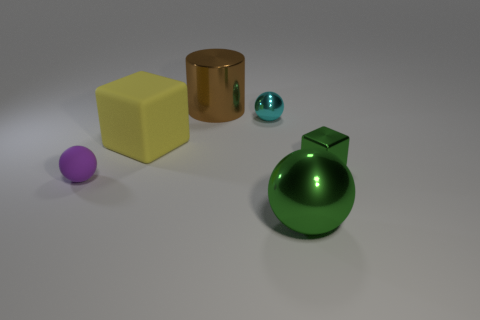What could be the material composition of each object based on their appearance? The big green sphere and the small blue sphere appear to have a reflective surface, suggesting they could be made of polished metal or glass. The yellow cube looks like it could be made of a matte plastic or rubber, whereas the cylinder has a reflective gold-like surface that indicates it could be a polished metal. How does the texture contribute to the perceived material of the objects? Texture plays a crucial role in material perception. Smooth, shiny textures suggest reflective materials like glass or metal, while dull, rough textures imply non-reflective materials like plastic or rubber. The absence of visible texture on these objects reinforces their perceived material properties, with the smooth objects suggesting a polished, reflective material and the cube's even coloration indicating a matte, non-reflective surface. 